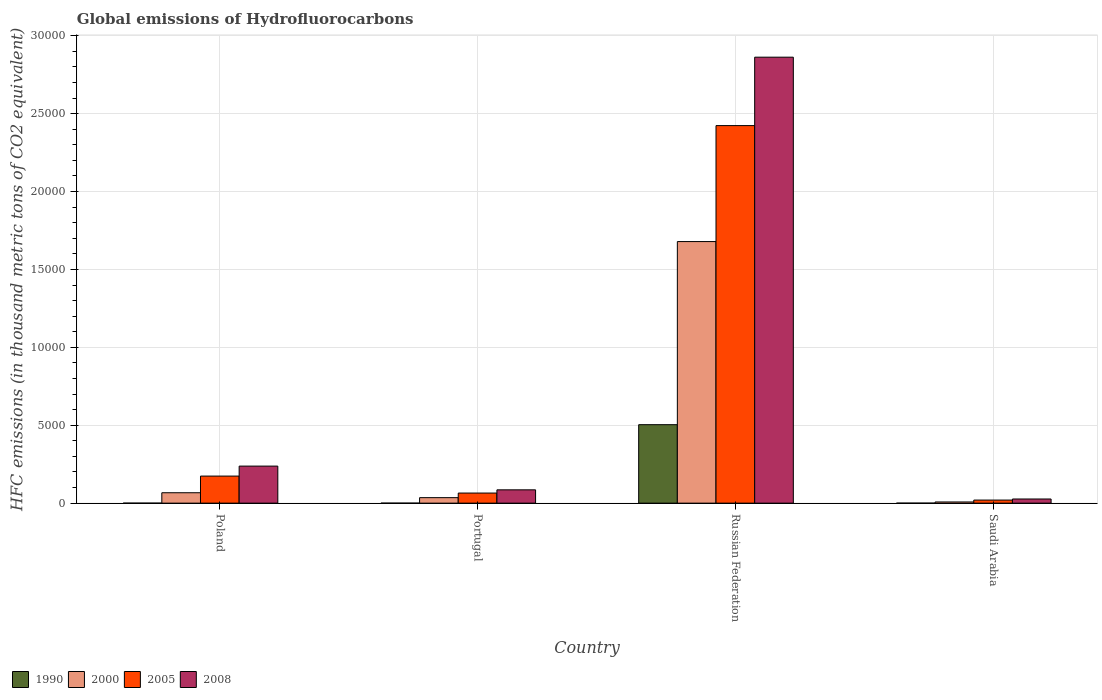How many different coloured bars are there?
Your response must be concise. 4. Are the number of bars per tick equal to the number of legend labels?
Provide a succinct answer. Yes. How many bars are there on the 3rd tick from the left?
Offer a very short reply. 4. How many bars are there on the 4th tick from the right?
Offer a very short reply. 4. What is the label of the 4th group of bars from the left?
Your response must be concise. Saudi Arabia. In how many cases, is the number of bars for a given country not equal to the number of legend labels?
Make the answer very short. 0. What is the global emissions of Hydrofluorocarbons in 2008 in Portugal?
Make the answer very short. 854.4. Across all countries, what is the maximum global emissions of Hydrofluorocarbons in 1990?
Offer a terse response. 5035.6. Across all countries, what is the minimum global emissions of Hydrofluorocarbons in 1990?
Your response must be concise. 0.1. In which country was the global emissions of Hydrofluorocarbons in 1990 maximum?
Give a very brief answer. Russian Federation. In which country was the global emissions of Hydrofluorocarbons in 1990 minimum?
Give a very brief answer. Poland. What is the total global emissions of Hydrofluorocarbons in 1990 in the graph?
Provide a succinct answer. 5036. What is the difference between the global emissions of Hydrofluorocarbons in 2008 in Portugal and that in Russian Federation?
Your answer should be very brief. -2.78e+04. What is the difference between the global emissions of Hydrofluorocarbons in 1990 in Saudi Arabia and the global emissions of Hydrofluorocarbons in 2000 in Portugal?
Your response must be concise. -352.6. What is the average global emissions of Hydrofluorocarbons in 2000 per country?
Ensure brevity in your answer.  4471.03. What is the difference between the global emissions of Hydrofluorocarbons of/in 2000 and global emissions of Hydrofluorocarbons of/in 1990 in Saudi Arabia?
Your answer should be compact. 75.4. In how many countries, is the global emissions of Hydrofluorocarbons in 2005 greater than 7000 thousand metric tons?
Make the answer very short. 1. What is the ratio of the global emissions of Hydrofluorocarbons in 1990 in Poland to that in Portugal?
Offer a terse response. 0.5. Is the global emissions of Hydrofluorocarbons in 2005 in Poland less than that in Russian Federation?
Ensure brevity in your answer.  Yes. What is the difference between the highest and the second highest global emissions of Hydrofluorocarbons in 2008?
Give a very brief answer. 1523.6. What is the difference between the highest and the lowest global emissions of Hydrofluorocarbons in 2005?
Offer a terse response. 2.40e+04. In how many countries, is the global emissions of Hydrofluorocarbons in 2000 greater than the average global emissions of Hydrofluorocarbons in 2000 taken over all countries?
Offer a terse response. 1. Is the sum of the global emissions of Hydrofluorocarbons in 1990 in Portugal and Russian Federation greater than the maximum global emissions of Hydrofluorocarbons in 2005 across all countries?
Provide a short and direct response. No. What does the 2nd bar from the left in Poland represents?
Offer a terse response. 2000. How many bars are there?
Your answer should be very brief. 16. Are all the bars in the graph horizontal?
Make the answer very short. No. Does the graph contain grids?
Your response must be concise. Yes. How many legend labels are there?
Your response must be concise. 4. How are the legend labels stacked?
Provide a short and direct response. Horizontal. What is the title of the graph?
Offer a terse response. Global emissions of Hydrofluorocarbons. What is the label or title of the X-axis?
Offer a very short reply. Country. What is the label or title of the Y-axis?
Offer a terse response. HFC emissions (in thousand metric tons of CO2 equivalent). What is the HFC emissions (in thousand metric tons of CO2 equivalent) of 1990 in Poland?
Ensure brevity in your answer.  0.1. What is the HFC emissions (in thousand metric tons of CO2 equivalent) of 2000 in Poland?
Your answer should be very brief. 667.2. What is the HFC emissions (in thousand metric tons of CO2 equivalent) of 2005 in Poland?
Your answer should be very brief. 1736.7. What is the HFC emissions (in thousand metric tons of CO2 equivalent) of 2008 in Poland?
Give a very brief answer. 2378. What is the HFC emissions (in thousand metric tons of CO2 equivalent) of 2000 in Portugal?
Keep it short and to the point. 352.7. What is the HFC emissions (in thousand metric tons of CO2 equivalent) of 2005 in Portugal?
Provide a short and direct response. 647.7. What is the HFC emissions (in thousand metric tons of CO2 equivalent) in 2008 in Portugal?
Your answer should be very brief. 854.4. What is the HFC emissions (in thousand metric tons of CO2 equivalent) in 1990 in Russian Federation?
Offer a very short reply. 5035.6. What is the HFC emissions (in thousand metric tons of CO2 equivalent) in 2000 in Russian Federation?
Ensure brevity in your answer.  1.68e+04. What is the HFC emissions (in thousand metric tons of CO2 equivalent) of 2005 in Russian Federation?
Provide a short and direct response. 2.42e+04. What is the HFC emissions (in thousand metric tons of CO2 equivalent) of 2008 in Russian Federation?
Give a very brief answer. 2.86e+04. What is the HFC emissions (in thousand metric tons of CO2 equivalent) of 2000 in Saudi Arabia?
Keep it short and to the point. 75.5. What is the HFC emissions (in thousand metric tons of CO2 equivalent) in 2005 in Saudi Arabia?
Your answer should be very brief. 196.9. What is the HFC emissions (in thousand metric tons of CO2 equivalent) in 2008 in Saudi Arabia?
Offer a very short reply. 266.5. Across all countries, what is the maximum HFC emissions (in thousand metric tons of CO2 equivalent) of 1990?
Give a very brief answer. 5035.6. Across all countries, what is the maximum HFC emissions (in thousand metric tons of CO2 equivalent) of 2000?
Ensure brevity in your answer.  1.68e+04. Across all countries, what is the maximum HFC emissions (in thousand metric tons of CO2 equivalent) of 2005?
Offer a terse response. 2.42e+04. Across all countries, what is the maximum HFC emissions (in thousand metric tons of CO2 equivalent) in 2008?
Give a very brief answer. 2.86e+04. Across all countries, what is the minimum HFC emissions (in thousand metric tons of CO2 equivalent) in 2000?
Offer a terse response. 75.5. Across all countries, what is the minimum HFC emissions (in thousand metric tons of CO2 equivalent) in 2005?
Offer a very short reply. 196.9. Across all countries, what is the minimum HFC emissions (in thousand metric tons of CO2 equivalent) of 2008?
Your response must be concise. 266.5. What is the total HFC emissions (in thousand metric tons of CO2 equivalent) in 1990 in the graph?
Provide a short and direct response. 5036. What is the total HFC emissions (in thousand metric tons of CO2 equivalent) in 2000 in the graph?
Your answer should be very brief. 1.79e+04. What is the total HFC emissions (in thousand metric tons of CO2 equivalent) of 2005 in the graph?
Offer a terse response. 2.68e+04. What is the total HFC emissions (in thousand metric tons of CO2 equivalent) of 2008 in the graph?
Your response must be concise. 3.21e+04. What is the difference between the HFC emissions (in thousand metric tons of CO2 equivalent) of 1990 in Poland and that in Portugal?
Keep it short and to the point. -0.1. What is the difference between the HFC emissions (in thousand metric tons of CO2 equivalent) of 2000 in Poland and that in Portugal?
Provide a short and direct response. 314.5. What is the difference between the HFC emissions (in thousand metric tons of CO2 equivalent) in 2005 in Poland and that in Portugal?
Give a very brief answer. 1089. What is the difference between the HFC emissions (in thousand metric tons of CO2 equivalent) in 2008 in Poland and that in Portugal?
Your answer should be very brief. 1523.6. What is the difference between the HFC emissions (in thousand metric tons of CO2 equivalent) in 1990 in Poland and that in Russian Federation?
Your response must be concise. -5035.5. What is the difference between the HFC emissions (in thousand metric tons of CO2 equivalent) in 2000 in Poland and that in Russian Federation?
Provide a succinct answer. -1.61e+04. What is the difference between the HFC emissions (in thousand metric tons of CO2 equivalent) in 2005 in Poland and that in Russian Federation?
Make the answer very short. -2.25e+04. What is the difference between the HFC emissions (in thousand metric tons of CO2 equivalent) of 2008 in Poland and that in Russian Federation?
Your answer should be compact. -2.62e+04. What is the difference between the HFC emissions (in thousand metric tons of CO2 equivalent) in 1990 in Poland and that in Saudi Arabia?
Give a very brief answer. 0. What is the difference between the HFC emissions (in thousand metric tons of CO2 equivalent) in 2000 in Poland and that in Saudi Arabia?
Your answer should be compact. 591.7. What is the difference between the HFC emissions (in thousand metric tons of CO2 equivalent) in 2005 in Poland and that in Saudi Arabia?
Give a very brief answer. 1539.8. What is the difference between the HFC emissions (in thousand metric tons of CO2 equivalent) of 2008 in Poland and that in Saudi Arabia?
Provide a short and direct response. 2111.5. What is the difference between the HFC emissions (in thousand metric tons of CO2 equivalent) of 1990 in Portugal and that in Russian Federation?
Give a very brief answer. -5035.4. What is the difference between the HFC emissions (in thousand metric tons of CO2 equivalent) in 2000 in Portugal and that in Russian Federation?
Your answer should be very brief. -1.64e+04. What is the difference between the HFC emissions (in thousand metric tons of CO2 equivalent) in 2005 in Portugal and that in Russian Federation?
Offer a terse response. -2.36e+04. What is the difference between the HFC emissions (in thousand metric tons of CO2 equivalent) in 2008 in Portugal and that in Russian Federation?
Your answer should be very brief. -2.78e+04. What is the difference between the HFC emissions (in thousand metric tons of CO2 equivalent) of 1990 in Portugal and that in Saudi Arabia?
Your answer should be very brief. 0.1. What is the difference between the HFC emissions (in thousand metric tons of CO2 equivalent) in 2000 in Portugal and that in Saudi Arabia?
Your response must be concise. 277.2. What is the difference between the HFC emissions (in thousand metric tons of CO2 equivalent) of 2005 in Portugal and that in Saudi Arabia?
Your answer should be very brief. 450.8. What is the difference between the HFC emissions (in thousand metric tons of CO2 equivalent) in 2008 in Portugal and that in Saudi Arabia?
Offer a terse response. 587.9. What is the difference between the HFC emissions (in thousand metric tons of CO2 equivalent) in 1990 in Russian Federation and that in Saudi Arabia?
Keep it short and to the point. 5035.5. What is the difference between the HFC emissions (in thousand metric tons of CO2 equivalent) of 2000 in Russian Federation and that in Saudi Arabia?
Make the answer very short. 1.67e+04. What is the difference between the HFC emissions (in thousand metric tons of CO2 equivalent) in 2005 in Russian Federation and that in Saudi Arabia?
Make the answer very short. 2.40e+04. What is the difference between the HFC emissions (in thousand metric tons of CO2 equivalent) in 2008 in Russian Federation and that in Saudi Arabia?
Give a very brief answer. 2.84e+04. What is the difference between the HFC emissions (in thousand metric tons of CO2 equivalent) of 1990 in Poland and the HFC emissions (in thousand metric tons of CO2 equivalent) of 2000 in Portugal?
Your response must be concise. -352.6. What is the difference between the HFC emissions (in thousand metric tons of CO2 equivalent) of 1990 in Poland and the HFC emissions (in thousand metric tons of CO2 equivalent) of 2005 in Portugal?
Offer a very short reply. -647.6. What is the difference between the HFC emissions (in thousand metric tons of CO2 equivalent) in 1990 in Poland and the HFC emissions (in thousand metric tons of CO2 equivalent) in 2008 in Portugal?
Your response must be concise. -854.3. What is the difference between the HFC emissions (in thousand metric tons of CO2 equivalent) of 2000 in Poland and the HFC emissions (in thousand metric tons of CO2 equivalent) of 2008 in Portugal?
Ensure brevity in your answer.  -187.2. What is the difference between the HFC emissions (in thousand metric tons of CO2 equivalent) of 2005 in Poland and the HFC emissions (in thousand metric tons of CO2 equivalent) of 2008 in Portugal?
Provide a short and direct response. 882.3. What is the difference between the HFC emissions (in thousand metric tons of CO2 equivalent) in 1990 in Poland and the HFC emissions (in thousand metric tons of CO2 equivalent) in 2000 in Russian Federation?
Offer a terse response. -1.68e+04. What is the difference between the HFC emissions (in thousand metric tons of CO2 equivalent) in 1990 in Poland and the HFC emissions (in thousand metric tons of CO2 equivalent) in 2005 in Russian Federation?
Keep it short and to the point. -2.42e+04. What is the difference between the HFC emissions (in thousand metric tons of CO2 equivalent) in 1990 in Poland and the HFC emissions (in thousand metric tons of CO2 equivalent) in 2008 in Russian Federation?
Keep it short and to the point. -2.86e+04. What is the difference between the HFC emissions (in thousand metric tons of CO2 equivalent) in 2000 in Poland and the HFC emissions (in thousand metric tons of CO2 equivalent) in 2005 in Russian Federation?
Give a very brief answer. -2.36e+04. What is the difference between the HFC emissions (in thousand metric tons of CO2 equivalent) of 2000 in Poland and the HFC emissions (in thousand metric tons of CO2 equivalent) of 2008 in Russian Federation?
Your response must be concise. -2.80e+04. What is the difference between the HFC emissions (in thousand metric tons of CO2 equivalent) in 2005 in Poland and the HFC emissions (in thousand metric tons of CO2 equivalent) in 2008 in Russian Federation?
Make the answer very short. -2.69e+04. What is the difference between the HFC emissions (in thousand metric tons of CO2 equivalent) in 1990 in Poland and the HFC emissions (in thousand metric tons of CO2 equivalent) in 2000 in Saudi Arabia?
Ensure brevity in your answer.  -75.4. What is the difference between the HFC emissions (in thousand metric tons of CO2 equivalent) in 1990 in Poland and the HFC emissions (in thousand metric tons of CO2 equivalent) in 2005 in Saudi Arabia?
Your answer should be compact. -196.8. What is the difference between the HFC emissions (in thousand metric tons of CO2 equivalent) of 1990 in Poland and the HFC emissions (in thousand metric tons of CO2 equivalent) of 2008 in Saudi Arabia?
Your response must be concise. -266.4. What is the difference between the HFC emissions (in thousand metric tons of CO2 equivalent) of 2000 in Poland and the HFC emissions (in thousand metric tons of CO2 equivalent) of 2005 in Saudi Arabia?
Offer a very short reply. 470.3. What is the difference between the HFC emissions (in thousand metric tons of CO2 equivalent) in 2000 in Poland and the HFC emissions (in thousand metric tons of CO2 equivalent) in 2008 in Saudi Arabia?
Make the answer very short. 400.7. What is the difference between the HFC emissions (in thousand metric tons of CO2 equivalent) of 2005 in Poland and the HFC emissions (in thousand metric tons of CO2 equivalent) of 2008 in Saudi Arabia?
Provide a short and direct response. 1470.2. What is the difference between the HFC emissions (in thousand metric tons of CO2 equivalent) of 1990 in Portugal and the HFC emissions (in thousand metric tons of CO2 equivalent) of 2000 in Russian Federation?
Provide a short and direct response. -1.68e+04. What is the difference between the HFC emissions (in thousand metric tons of CO2 equivalent) in 1990 in Portugal and the HFC emissions (in thousand metric tons of CO2 equivalent) in 2005 in Russian Federation?
Make the answer very short. -2.42e+04. What is the difference between the HFC emissions (in thousand metric tons of CO2 equivalent) of 1990 in Portugal and the HFC emissions (in thousand metric tons of CO2 equivalent) of 2008 in Russian Federation?
Your response must be concise. -2.86e+04. What is the difference between the HFC emissions (in thousand metric tons of CO2 equivalent) in 2000 in Portugal and the HFC emissions (in thousand metric tons of CO2 equivalent) in 2005 in Russian Federation?
Offer a very short reply. -2.39e+04. What is the difference between the HFC emissions (in thousand metric tons of CO2 equivalent) of 2000 in Portugal and the HFC emissions (in thousand metric tons of CO2 equivalent) of 2008 in Russian Federation?
Make the answer very short. -2.83e+04. What is the difference between the HFC emissions (in thousand metric tons of CO2 equivalent) in 2005 in Portugal and the HFC emissions (in thousand metric tons of CO2 equivalent) in 2008 in Russian Federation?
Your response must be concise. -2.80e+04. What is the difference between the HFC emissions (in thousand metric tons of CO2 equivalent) in 1990 in Portugal and the HFC emissions (in thousand metric tons of CO2 equivalent) in 2000 in Saudi Arabia?
Your answer should be very brief. -75.3. What is the difference between the HFC emissions (in thousand metric tons of CO2 equivalent) in 1990 in Portugal and the HFC emissions (in thousand metric tons of CO2 equivalent) in 2005 in Saudi Arabia?
Give a very brief answer. -196.7. What is the difference between the HFC emissions (in thousand metric tons of CO2 equivalent) in 1990 in Portugal and the HFC emissions (in thousand metric tons of CO2 equivalent) in 2008 in Saudi Arabia?
Your response must be concise. -266.3. What is the difference between the HFC emissions (in thousand metric tons of CO2 equivalent) of 2000 in Portugal and the HFC emissions (in thousand metric tons of CO2 equivalent) of 2005 in Saudi Arabia?
Your answer should be very brief. 155.8. What is the difference between the HFC emissions (in thousand metric tons of CO2 equivalent) of 2000 in Portugal and the HFC emissions (in thousand metric tons of CO2 equivalent) of 2008 in Saudi Arabia?
Your answer should be very brief. 86.2. What is the difference between the HFC emissions (in thousand metric tons of CO2 equivalent) in 2005 in Portugal and the HFC emissions (in thousand metric tons of CO2 equivalent) in 2008 in Saudi Arabia?
Make the answer very short. 381.2. What is the difference between the HFC emissions (in thousand metric tons of CO2 equivalent) of 1990 in Russian Federation and the HFC emissions (in thousand metric tons of CO2 equivalent) of 2000 in Saudi Arabia?
Provide a succinct answer. 4960.1. What is the difference between the HFC emissions (in thousand metric tons of CO2 equivalent) of 1990 in Russian Federation and the HFC emissions (in thousand metric tons of CO2 equivalent) of 2005 in Saudi Arabia?
Offer a very short reply. 4838.7. What is the difference between the HFC emissions (in thousand metric tons of CO2 equivalent) of 1990 in Russian Federation and the HFC emissions (in thousand metric tons of CO2 equivalent) of 2008 in Saudi Arabia?
Your answer should be compact. 4769.1. What is the difference between the HFC emissions (in thousand metric tons of CO2 equivalent) of 2000 in Russian Federation and the HFC emissions (in thousand metric tons of CO2 equivalent) of 2005 in Saudi Arabia?
Your answer should be very brief. 1.66e+04. What is the difference between the HFC emissions (in thousand metric tons of CO2 equivalent) of 2000 in Russian Federation and the HFC emissions (in thousand metric tons of CO2 equivalent) of 2008 in Saudi Arabia?
Keep it short and to the point. 1.65e+04. What is the difference between the HFC emissions (in thousand metric tons of CO2 equivalent) in 2005 in Russian Federation and the HFC emissions (in thousand metric tons of CO2 equivalent) in 2008 in Saudi Arabia?
Ensure brevity in your answer.  2.40e+04. What is the average HFC emissions (in thousand metric tons of CO2 equivalent) in 1990 per country?
Make the answer very short. 1259. What is the average HFC emissions (in thousand metric tons of CO2 equivalent) of 2000 per country?
Provide a succinct answer. 4471.02. What is the average HFC emissions (in thousand metric tons of CO2 equivalent) of 2005 per country?
Ensure brevity in your answer.  6703.15. What is the average HFC emissions (in thousand metric tons of CO2 equivalent) of 2008 per country?
Offer a terse response. 8030.6. What is the difference between the HFC emissions (in thousand metric tons of CO2 equivalent) of 1990 and HFC emissions (in thousand metric tons of CO2 equivalent) of 2000 in Poland?
Provide a succinct answer. -667.1. What is the difference between the HFC emissions (in thousand metric tons of CO2 equivalent) of 1990 and HFC emissions (in thousand metric tons of CO2 equivalent) of 2005 in Poland?
Offer a very short reply. -1736.6. What is the difference between the HFC emissions (in thousand metric tons of CO2 equivalent) in 1990 and HFC emissions (in thousand metric tons of CO2 equivalent) in 2008 in Poland?
Ensure brevity in your answer.  -2377.9. What is the difference between the HFC emissions (in thousand metric tons of CO2 equivalent) in 2000 and HFC emissions (in thousand metric tons of CO2 equivalent) in 2005 in Poland?
Your answer should be compact. -1069.5. What is the difference between the HFC emissions (in thousand metric tons of CO2 equivalent) in 2000 and HFC emissions (in thousand metric tons of CO2 equivalent) in 2008 in Poland?
Provide a short and direct response. -1710.8. What is the difference between the HFC emissions (in thousand metric tons of CO2 equivalent) of 2005 and HFC emissions (in thousand metric tons of CO2 equivalent) of 2008 in Poland?
Keep it short and to the point. -641.3. What is the difference between the HFC emissions (in thousand metric tons of CO2 equivalent) in 1990 and HFC emissions (in thousand metric tons of CO2 equivalent) in 2000 in Portugal?
Keep it short and to the point. -352.5. What is the difference between the HFC emissions (in thousand metric tons of CO2 equivalent) of 1990 and HFC emissions (in thousand metric tons of CO2 equivalent) of 2005 in Portugal?
Your response must be concise. -647.5. What is the difference between the HFC emissions (in thousand metric tons of CO2 equivalent) in 1990 and HFC emissions (in thousand metric tons of CO2 equivalent) in 2008 in Portugal?
Your answer should be very brief. -854.2. What is the difference between the HFC emissions (in thousand metric tons of CO2 equivalent) in 2000 and HFC emissions (in thousand metric tons of CO2 equivalent) in 2005 in Portugal?
Offer a terse response. -295. What is the difference between the HFC emissions (in thousand metric tons of CO2 equivalent) of 2000 and HFC emissions (in thousand metric tons of CO2 equivalent) of 2008 in Portugal?
Provide a short and direct response. -501.7. What is the difference between the HFC emissions (in thousand metric tons of CO2 equivalent) of 2005 and HFC emissions (in thousand metric tons of CO2 equivalent) of 2008 in Portugal?
Your answer should be compact. -206.7. What is the difference between the HFC emissions (in thousand metric tons of CO2 equivalent) of 1990 and HFC emissions (in thousand metric tons of CO2 equivalent) of 2000 in Russian Federation?
Give a very brief answer. -1.18e+04. What is the difference between the HFC emissions (in thousand metric tons of CO2 equivalent) of 1990 and HFC emissions (in thousand metric tons of CO2 equivalent) of 2005 in Russian Federation?
Your response must be concise. -1.92e+04. What is the difference between the HFC emissions (in thousand metric tons of CO2 equivalent) of 1990 and HFC emissions (in thousand metric tons of CO2 equivalent) of 2008 in Russian Federation?
Provide a short and direct response. -2.36e+04. What is the difference between the HFC emissions (in thousand metric tons of CO2 equivalent) of 2000 and HFC emissions (in thousand metric tons of CO2 equivalent) of 2005 in Russian Federation?
Ensure brevity in your answer.  -7442.6. What is the difference between the HFC emissions (in thousand metric tons of CO2 equivalent) in 2000 and HFC emissions (in thousand metric tons of CO2 equivalent) in 2008 in Russian Federation?
Provide a succinct answer. -1.18e+04. What is the difference between the HFC emissions (in thousand metric tons of CO2 equivalent) in 2005 and HFC emissions (in thousand metric tons of CO2 equivalent) in 2008 in Russian Federation?
Your answer should be very brief. -4392.2. What is the difference between the HFC emissions (in thousand metric tons of CO2 equivalent) in 1990 and HFC emissions (in thousand metric tons of CO2 equivalent) in 2000 in Saudi Arabia?
Ensure brevity in your answer.  -75.4. What is the difference between the HFC emissions (in thousand metric tons of CO2 equivalent) in 1990 and HFC emissions (in thousand metric tons of CO2 equivalent) in 2005 in Saudi Arabia?
Offer a very short reply. -196.8. What is the difference between the HFC emissions (in thousand metric tons of CO2 equivalent) in 1990 and HFC emissions (in thousand metric tons of CO2 equivalent) in 2008 in Saudi Arabia?
Offer a very short reply. -266.4. What is the difference between the HFC emissions (in thousand metric tons of CO2 equivalent) in 2000 and HFC emissions (in thousand metric tons of CO2 equivalent) in 2005 in Saudi Arabia?
Give a very brief answer. -121.4. What is the difference between the HFC emissions (in thousand metric tons of CO2 equivalent) in 2000 and HFC emissions (in thousand metric tons of CO2 equivalent) in 2008 in Saudi Arabia?
Your answer should be very brief. -191. What is the difference between the HFC emissions (in thousand metric tons of CO2 equivalent) in 2005 and HFC emissions (in thousand metric tons of CO2 equivalent) in 2008 in Saudi Arabia?
Ensure brevity in your answer.  -69.6. What is the ratio of the HFC emissions (in thousand metric tons of CO2 equivalent) in 1990 in Poland to that in Portugal?
Your answer should be very brief. 0.5. What is the ratio of the HFC emissions (in thousand metric tons of CO2 equivalent) in 2000 in Poland to that in Portugal?
Your response must be concise. 1.89. What is the ratio of the HFC emissions (in thousand metric tons of CO2 equivalent) of 2005 in Poland to that in Portugal?
Keep it short and to the point. 2.68. What is the ratio of the HFC emissions (in thousand metric tons of CO2 equivalent) of 2008 in Poland to that in Portugal?
Make the answer very short. 2.78. What is the ratio of the HFC emissions (in thousand metric tons of CO2 equivalent) in 1990 in Poland to that in Russian Federation?
Your response must be concise. 0. What is the ratio of the HFC emissions (in thousand metric tons of CO2 equivalent) of 2000 in Poland to that in Russian Federation?
Your response must be concise. 0.04. What is the ratio of the HFC emissions (in thousand metric tons of CO2 equivalent) of 2005 in Poland to that in Russian Federation?
Provide a short and direct response. 0.07. What is the ratio of the HFC emissions (in thousand metric tons of CO2 equivalent) in 2008 in Poland to that in Russian Federation?
Keep it short and to the point. 0.08. What is the ratio of the HFC emissions (in thousand metric tons of CO2 equivalent) in 1990 in Poland to that in Saudi Arabia?
Provide a short and direct response. 1. What is the ratio of the HFC emissions (in thousand metric tons of CO2 equivalent) in 2000 in Poland to that in Saudi Arabia?
Make the answer very short. 8.84. What is the ratio of the HFC emissions (in thousand metric tons of CO2 equivalent) of 2005 in Poland to that in Saudi Arabia?
Keep it short and to the point. 8.82. What is the ratio of the HFC emissions (in thousand metric tons of CO2 equivalent) in 2008 in Poland to that in Saudi Arabia?
Your answer should be compact. 8.92. What is the ratio of the HFC emissions (in thousand metric tons of CO2 equivalent) of 1990 in Portugal to that in Russian Federation?
Give a very brief answer. 0. What is the ratio of the HFC emissions (in thousand metric tons of CO2 equivalent) of 2000 in Portugal to that in Russian Federation?
Make the answer very short. 0.02. What is the ratio of the HFC emissions (in thousand metric tons of CO2 equivalent) of 2005 in Portugal to that in Russian Federation?
Your answer should be compact. 0.03. What is the ratio of the HFC emissions (in thousand metric tons of CO2 equivalent) of 2008 in Portugal to that in Russian Federation?
Offer a terse response. 0.03. What is the ratio of the HFC emissions (in thousand metric tons of CO2 equivalent) of 1990 in Portugal to that in Saudi Arabia?
Provide a short and direct response. 2. What is the ratio of the HFC emissions (in thousand metric tons of CO2 equivalent) of 2000 in Portugal to that in Saudi Arabia?
Make the answer very short. 4.67. What is the ratio of the HFC emissions (in thousand metric tons of CO2 equivalent) of 2005 in Portugal to that in Saudi Arabia?
Your answer should be compact. 3.29. What is the ratio of the HFC emissions (in thousand metric tons of CO2 equivalent) in 2008 in Portugal to that in Saudi Arabia?
Provide a succinct answer. 3.21. What is the ratio of the HFC emissions (in thousand metric tons of CO2 equivalent) in 1990 in Russian Federation to that in Saudi Arabia?
Provide a short and direct response. 5.04e+04. What is the ratio of the HFC emissions (in thousand metric tons of CO2 equivalent) of 2000 in Russian Federation to that in Saudi Arabia?
Keep it short and to the point. 222.37. What is the ratio of the HFC emissions (in thousand metric tons of CO2 equivalent) in 2005 in Russian Federation to that in Saudi Arabia?
Provide a short and direct response. 123.06. What is the ratio of the HFC emissions (in thousand metric tons of CO2 equivalent) in 2008 in Russian Federation to that in Saudi Arabia?
Your answer should be very brief. 107.41. What is the difference between the highest and the second highest HFC emissions (in thousand metric tons of CO2 equivalent) of 1990?
Your response must be concise. 5035.4. What is the difference between the highest and the second highest HFC emissions (in thousand metric tons of CO2 equivalent) of 2000?
Make the answer very short. 1.61e+04. What is the difference between the highest and the second highest HFC emissions (in thousand metric tons of CO2 equivalent) of 2005?
Your response must be concise. 2.25e+04. What is the difference between the highest and the second highest HFC emissions (in thousand metric tons of CO2 equivalent) of 2008?
Ensure brevity in your answer.  2.62e+04. What is the difference between the highest and the lowest HFC emissions (in thousand metric tons of CO2 equivalent) in 1990?
Give a very brief answer. 5035.5. What is the difference between the highest and the lowest HFC emissions (in thousand metric tons of CO2 equivalent) in 2000?
Keep it short and to the point. 1.67e+04. What is the difference between the highest and the lowest HFC emissions (in thousand metric tons of CO2 equivalent) in 2005?
Provide a short and direct response. 2.40e+04. What is the difference between the highest and the lowest HFC emissions (in thousand metric tons of CO2 equivalent) of 2008?
Your answer should be compact. 2.84e+04. 